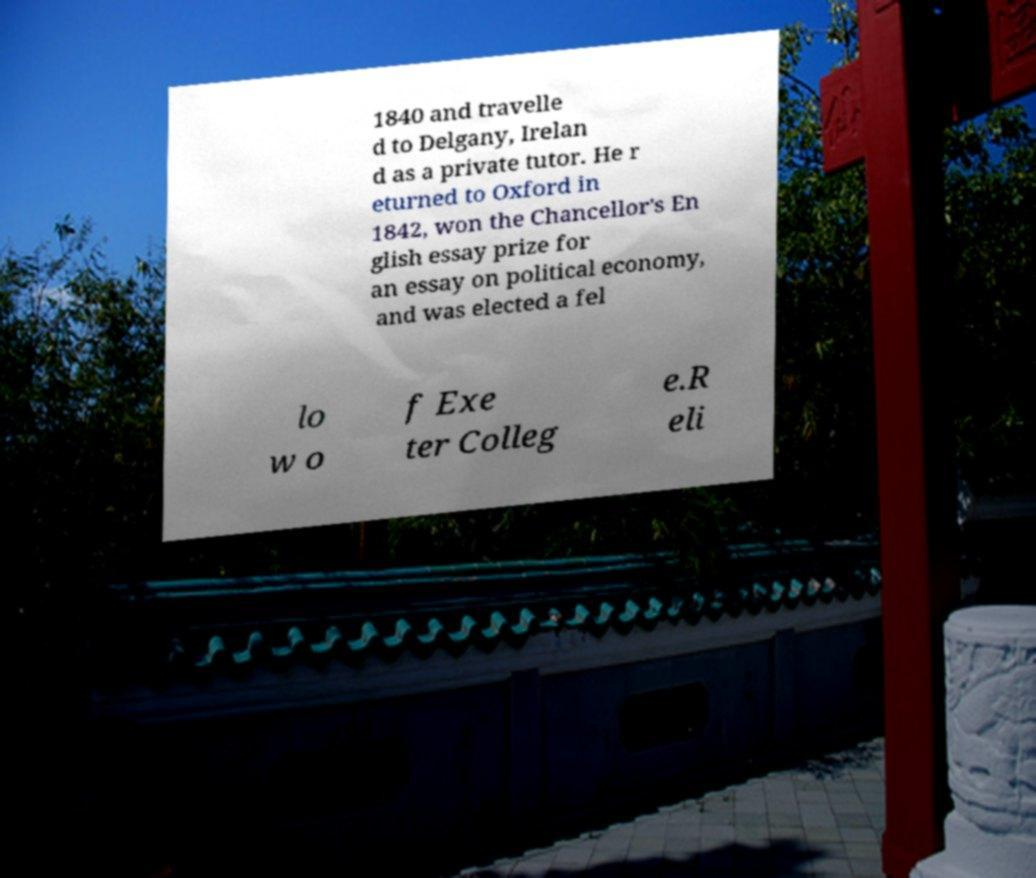Could you extract and type out the text from this image? 1840 and travelle d to Delgany, Irelan d as a private tutor. He r eturned to Oxford in 1842, won the Chancellor's En glish essay prize for an essay on political economy, and was elected a fel lo w o f Exe ter Colleg e.R eli 